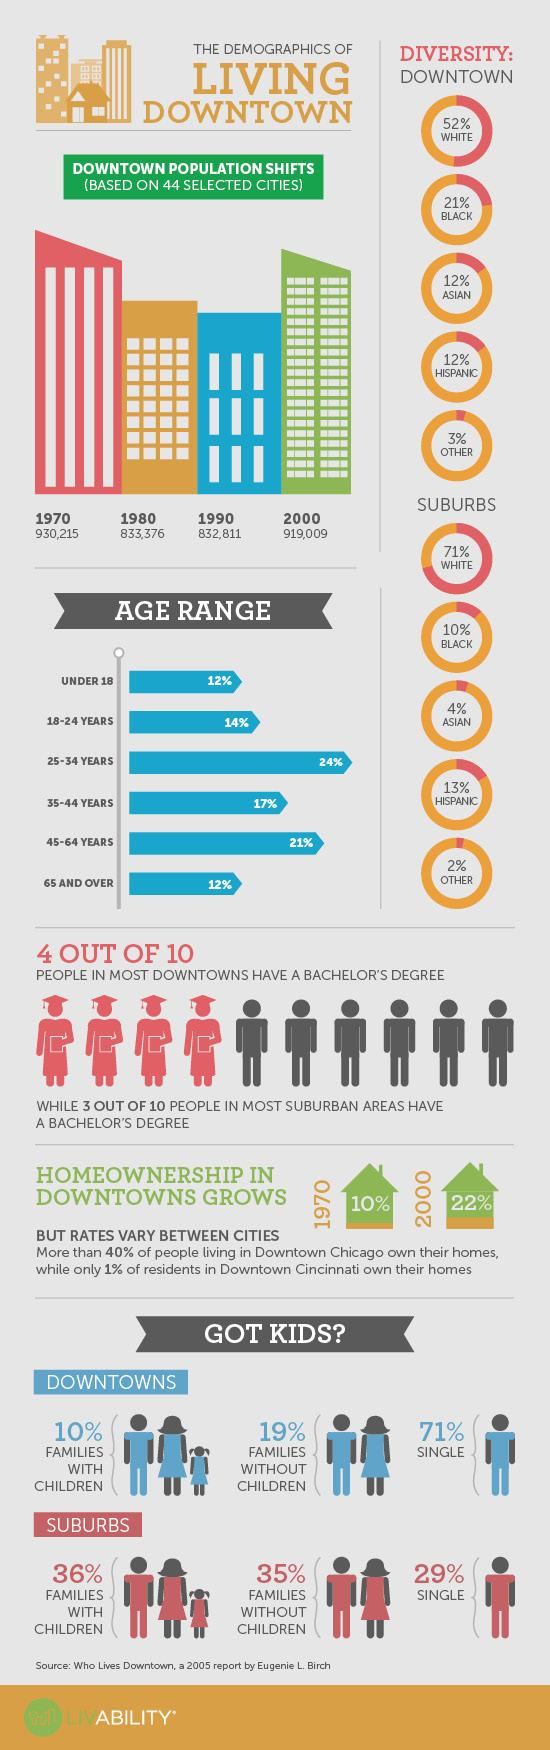Mention a couple of crucial points in this snapshot. The percentage of black and white people in the suburbs is 81%. According to the given information, 41% of the people aged 25-34 and 35-44 years taken together constitute a certain percentage. Out of 10 people from downtown, 6 did not have a bachelor's degree. In downtown, it is estimated that only 10% of families with children reside. In 1970, the downtown population was 11,206 people, while in 2000, it had increased to a total of 11,300 individuals. 